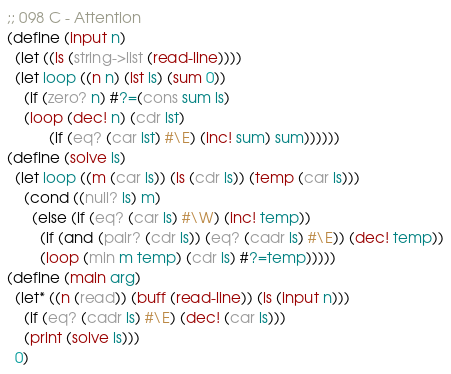Convert code to text. <code><loc_0><loc_0><loc_500><loc_500><_Scheme_>
;; 098 C - Attention
(define (input n)
  (let ((ls (string->list (read-line))))
  (let loop ((n n) (lst ls) (sum 0))
    (if (zero? n) #?=(cons sum ls)
	(loop (dec! n) (cdr lst)
	      (if (eq? (car lst) #\E) (inc! sum) sum))))))
(define (solve ls)
  (let loop ((m (car ls)) (ls (cdr ls)) (temp (car ls)))
    (cond ((null? ls) m)
	  (else (if (eq? (car ls) #\W) (inc! temp))
		(if (and (pair? (cdr ls)) (eq? (cadr ls) #\E)) (dec! temp))
		(loop (min m temp) (cdr ls) #?=temp)))))
(define (main arg)
  (let* ((n (read)) (buff (read-line)) (ls (input n)))
    (if (eq? (cadr ls) #\E) (dec! (car ls)))
    (print (solve ls)))
  0)
</code> 